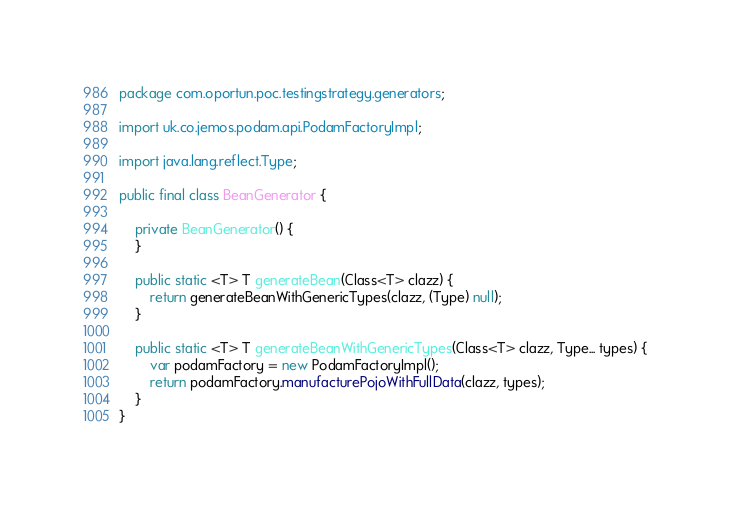Convert code to text. <code><loc_0><loc_0><loc_500><loc_500><_Java_>package com.oportun.poc.testingstrategy.generators;

import uk.co.jemos.podam.api.PodamFactoryImpl;

import java.lang.reflect.Type;

public final class BeanGenerator {

    private BeanGenerator() {
    }

    public static <T> T generateBean(Class<T> clazz) {
        return generateBeanWithGenericTypes(clazz, (Type) null);
    }

    public static <T> T generateBeanWithGenericTypes(Class<T> clazz, Type... types) {
        var podamFactory = new PodamFactoryImpl();
        return podamFactory.manufacturePojoWithFullData(clazz, types);
    }
}
</code> 